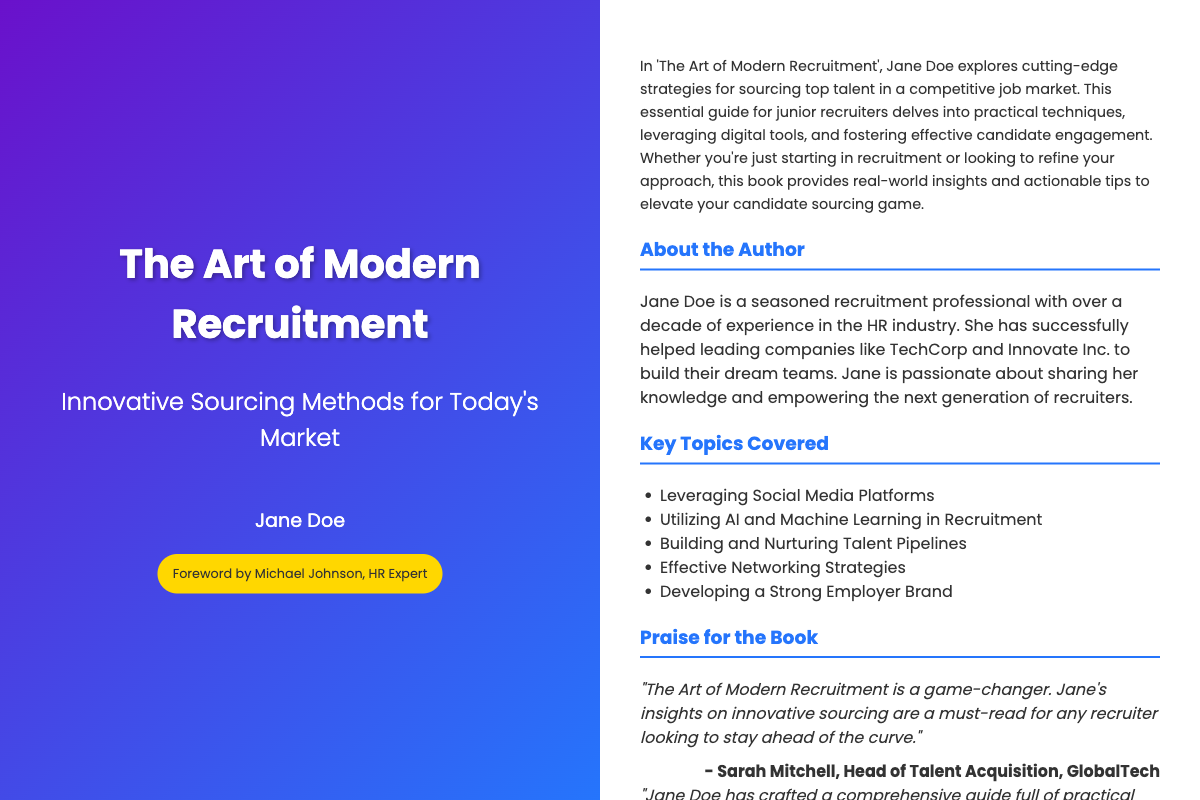What is the title of the book? The title is prominently displayed on the front cover of the document.
Answer: The Art of Modern Recruitment Who is the author of the book? The author's name is mentioned on the front cover underneath the title.
Answer: Jane Doe What are the key topics covered in the book? A list of key topics is provided on the back cover under the section titled "Key Topics Covered."
Answer: Leveraging Social Media Platforms, Utilizing AI and Machine Learning in Recruitment, Building and Nurturing Talent Pipelines, Effective Networking Strategies, Developing a Strong Employer Brand How many years of experience does the author have in the HR industry? The document states the author has over a decade of experience.
Answer: Over a decade Who wrote the foreword for the book? The foreword is acknowledged on the front cover, specifically under the author's name.
Answer: Michael Johnson What is the primary target audience for this book? The target audience is indicated in the summary section, specifically describing the intended readers.
Answer: Junior recruiters Which company did the author help build their teams according to the document? A specific example of a company the author worked with is mentioned in the "About the Author" section.
Answer: TechCorp What genre does this book belong to? The book is categorized based on its content and context in the recruitment industry.
Answer: Recruitment guide What type of strategies does the book focus on? The book emphasizes a particular focus on sourcing strategies within the recruitment context.
Answer: Innovative sourcing methods 